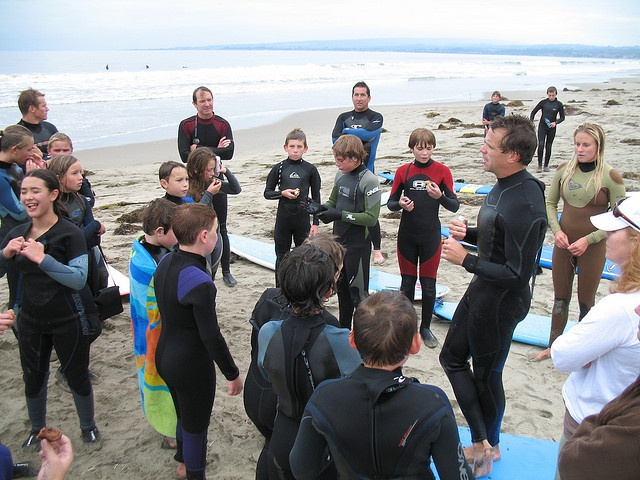Describe the objects in this image and their specific colors. I can see people in lightblue, black, gray, darkgray, and lightgray tones, people in lightblue, black, and gray tones, people in lightblue, black, gray, and darkblue tones, people in lightblue, black, gray, and navy tones, and people in lightblue, black, gray, and darkblue tones in this image. 